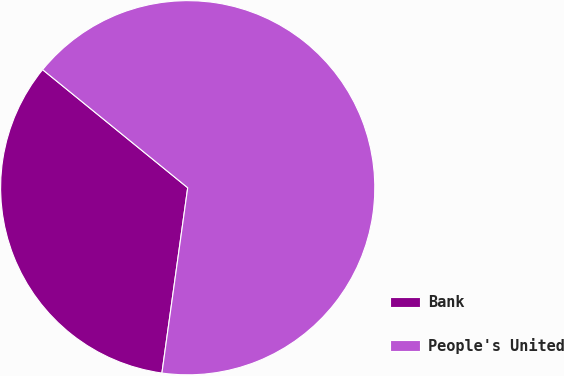<chart> <loc_0><loc_0><loc_500><loc_500><pie_chart><fcel>Bank<fcel>People's United<nl><fcel>33.67%<fcel>66.33%<nl></chart> 